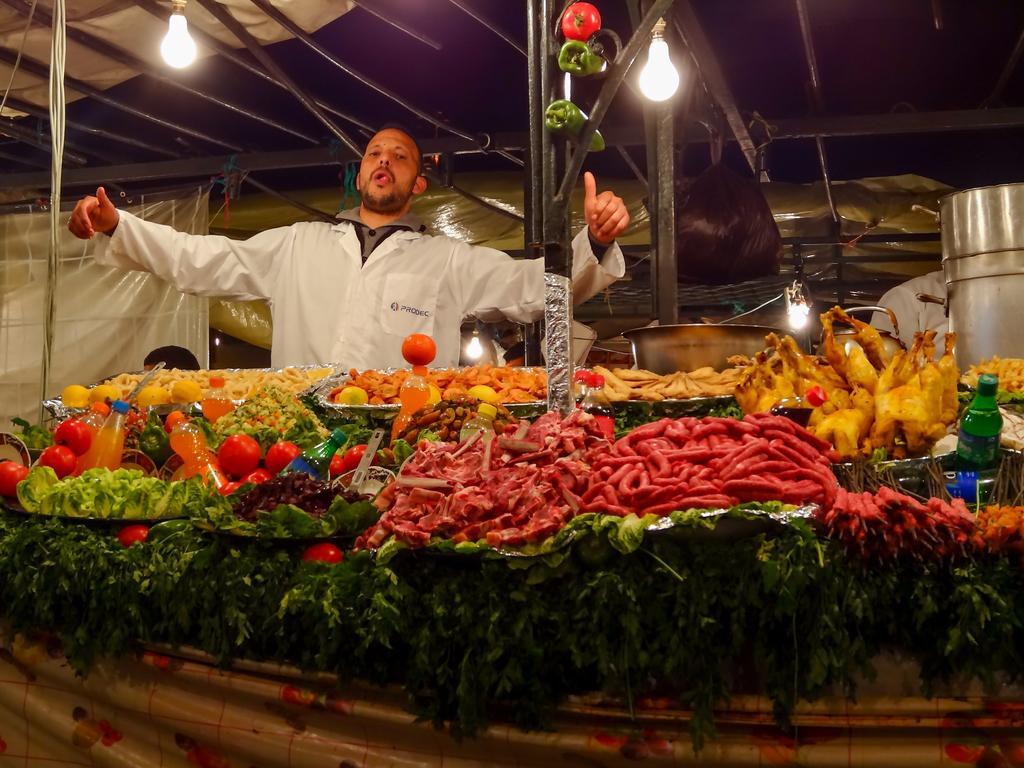Could you give a brief overview of what you see in this image? In this picture there is a man who is standing near to the table. On the table we can see the vegetables, water bottles, meet, tomato, leaves and other objects. In the background we can see cloth, lights and pipes. 